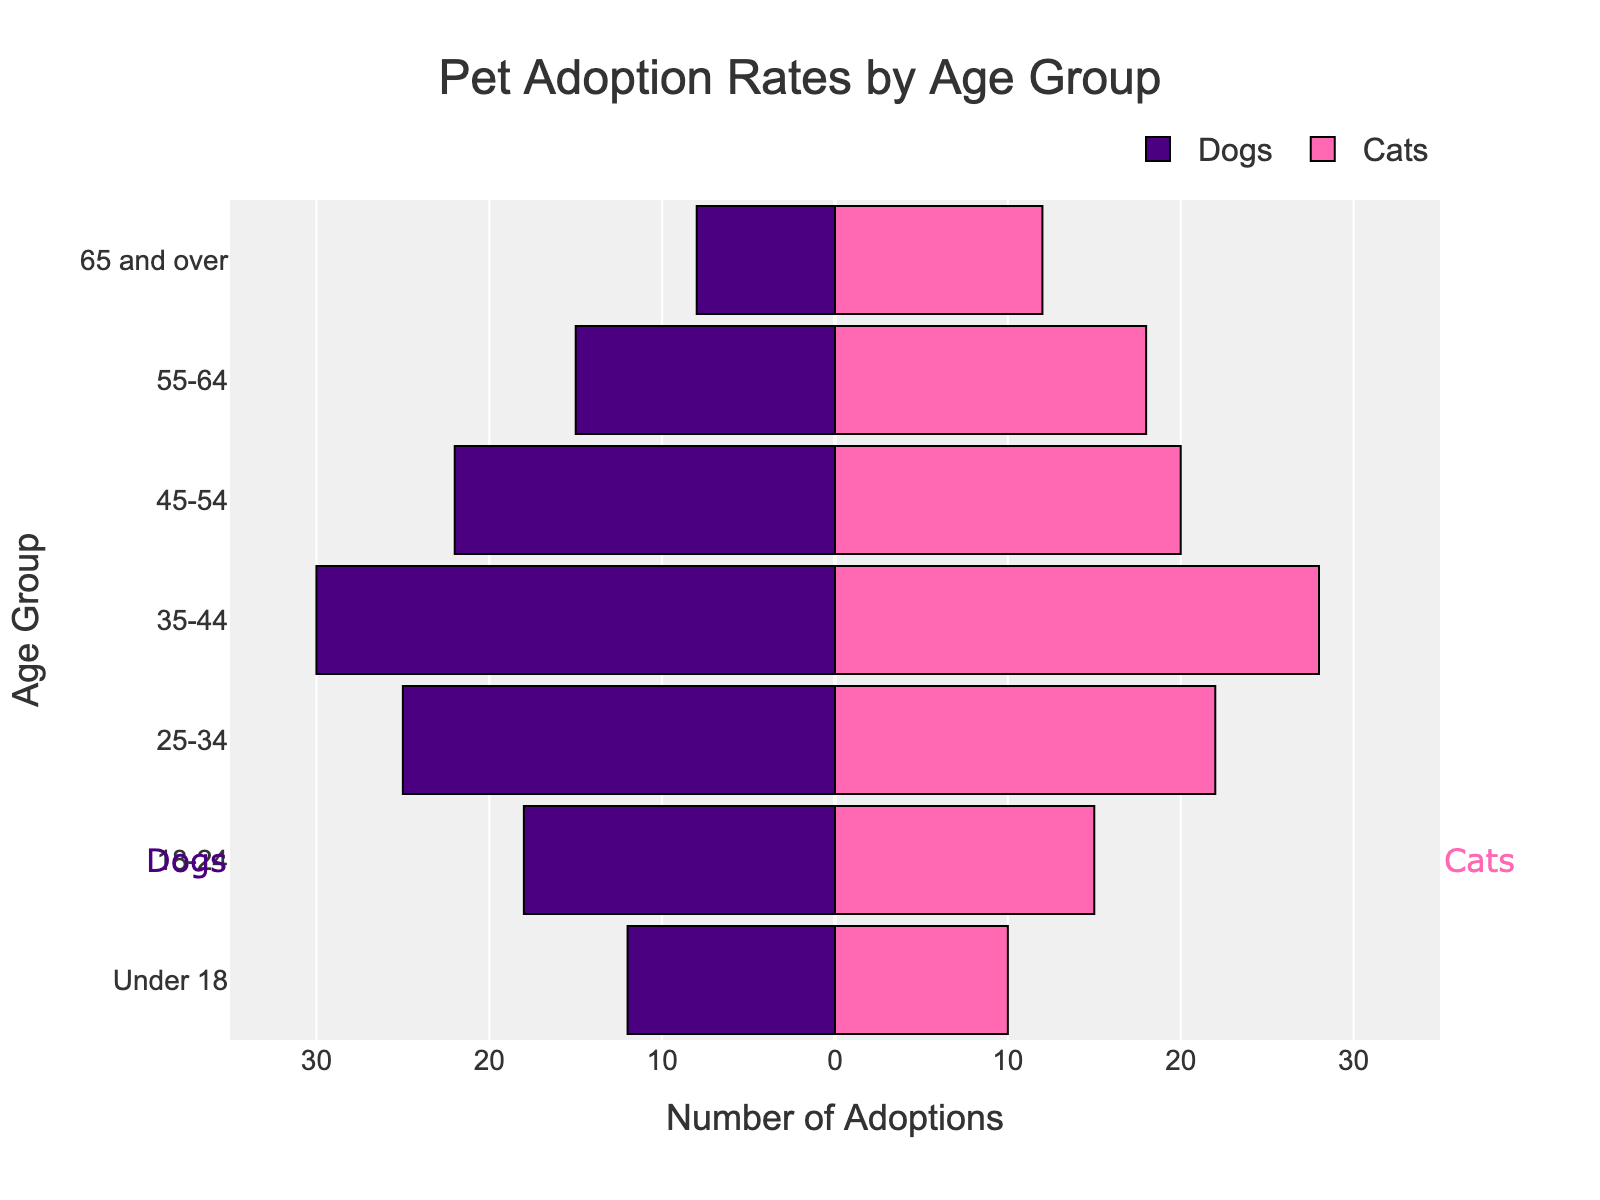What's the title of the figure? The title of the figure is usually found at the top, centered, and typically in a larger font. This assists viewers in immediately understanding what the figure represents.
Answer: Pet Adoption Rates by Age Group What age group shows the highest number of dog adoptions? By observing the lengths of the bars representing dog adoptions on the left side of the x-axis, the longest bar indicates the highest number of dog adoptions.
Answer: 35-44 Which age group has a higher number of cat adoptions compared to dog adoptions? By looking at each age group and comparing the lengths of the bars representing cat adoptions (right side) and dog adoptions (left side), we can identify which bars are longer for cats.
Answer: All age groups What's the total number of dog adoptions for age groups under 35? Sum the absolute values of the lengths of the bars corresponding to the 'Under 18', '18-24', and '25-34' age groups on the dog side.
Answer: 55 Which age group has the smallest difference between cat and dog adoptions? For each age group, subtract the number of dog adoptions from cat adoptions and identify the smallest difference. Comparison should be visual or through actual subtraction.
Answer: Under 18 What is the average number of cat adoptions across all age groups? Sum up the number of cat adoptions for all age groups and divide by the total number of age groups (7).
Answer: 17 Which age group has the closest adoption rates for both cats and dogs? Identify the age group where the lengths of the bars representing cats and dogs are closest to each other.
Answer: Under 18 In which age group do dog adoptions decrease significantly compared to the previous group? Observe the bars on the left side; compare the lengths between consecutive age groups to find where there is a substantial decrease.
Answer: 45-54 What's the trend in dog adoptions as the age groups increase? Observe the general direction of changes in the lengths of bars representing dog adoptions.
Answer: Decreasing What color is used to represent cat adoptions in the figure? The figure uses a specific color for cat adoptions. This can be determined by looking at the cat adoption bars or the legend.
Answer: Pink 